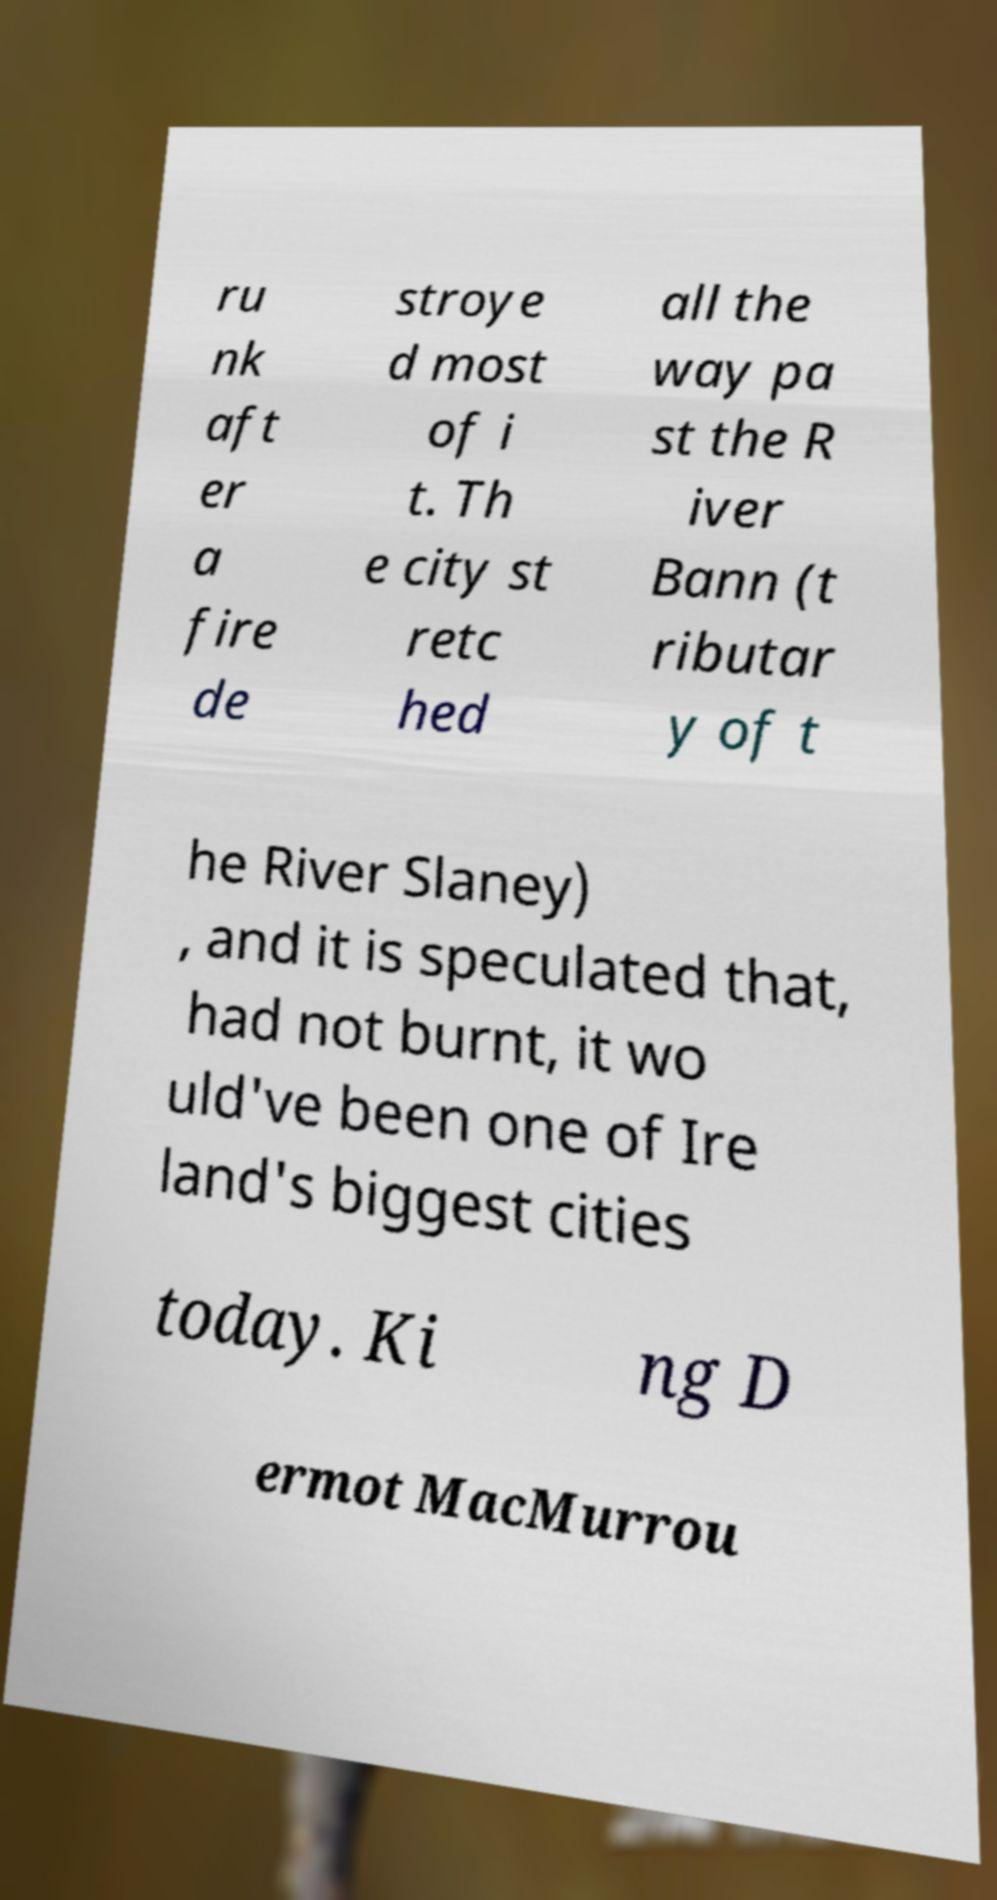Could you extract and type out the text from this image? ru nk aft er a fire de stroye d most of i t. Th e city st retc hed all the way pa st the R iver Bann (t ributar y of t he River Slaney) , and it is speculated that, had not burnt, it wo uld've been one of Ire land's biggest cities today. Ki ng D ermot MacMurrou 